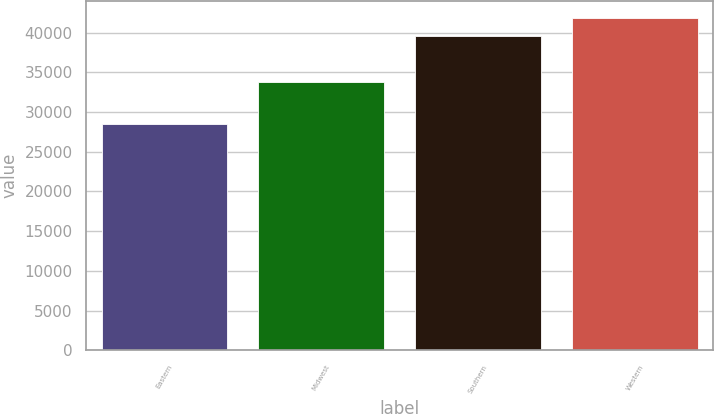Convert chart. <chart><loc_0><loc_0><loc_500><loc_500><bar_chart><fcel>Eastern<fcel>Midwest<fcel>Southern<fcel>Western<nl><fcel>28509<fcel>33829<fcel>39622<fcel>41870<nl></chart> 